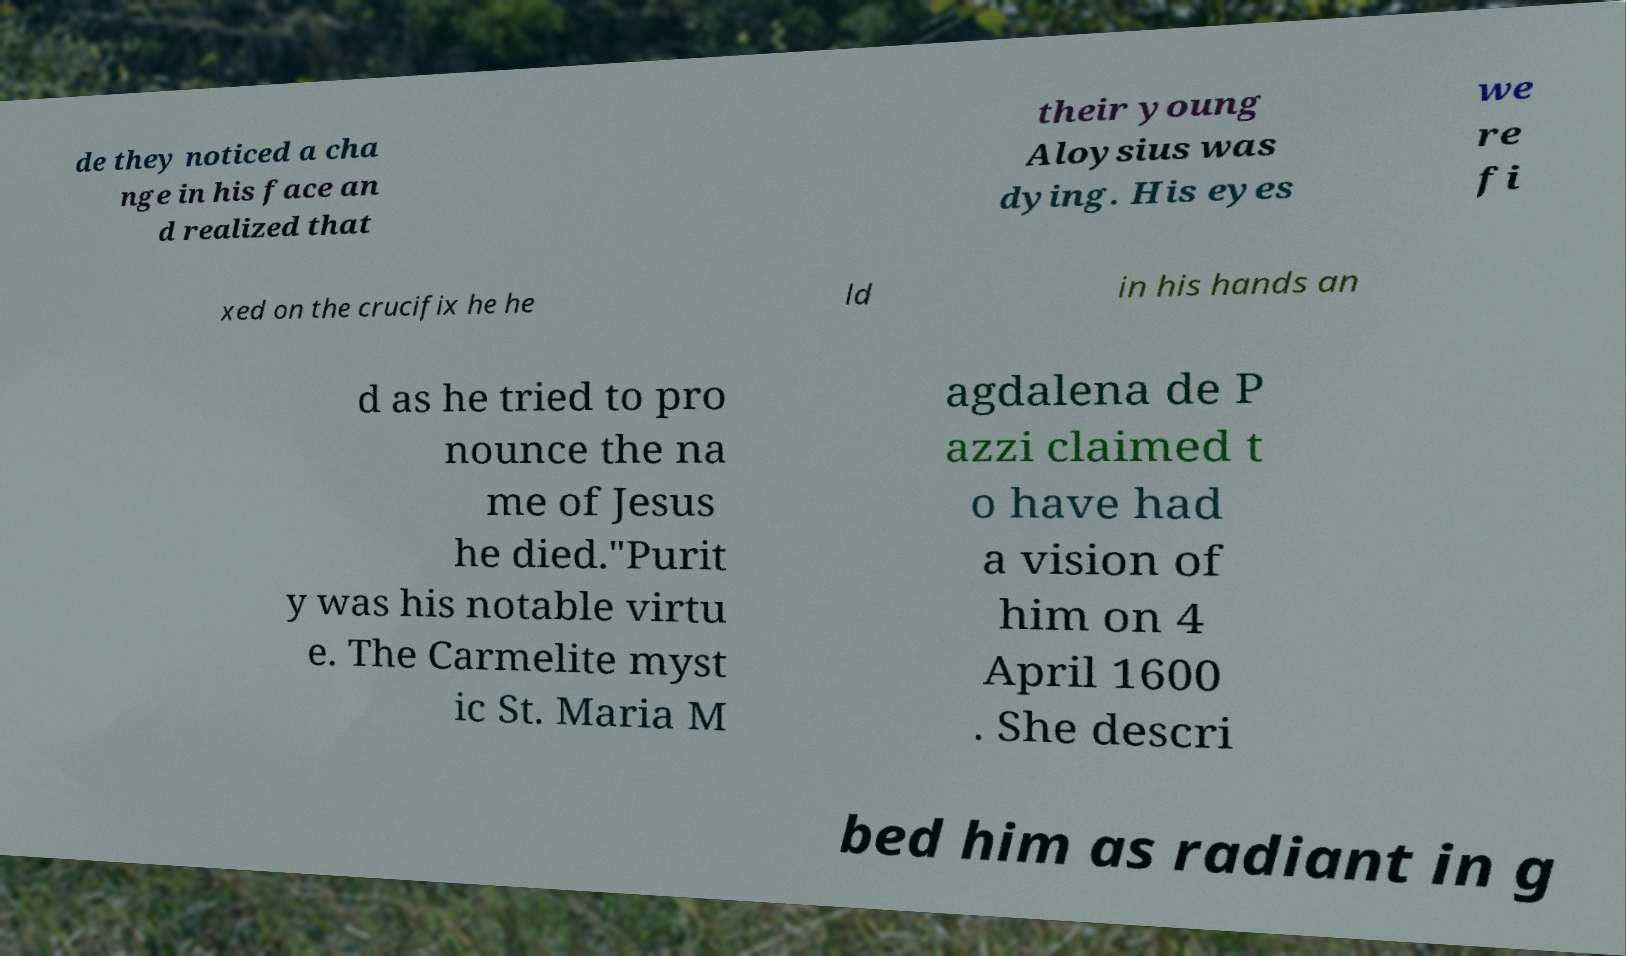Please read and relay the text visible in this image. What does it say? de they noticed a cha nge in his face an d realized that their young Aloysius was dying. His eyes we re fi xed on the crucifix he he ld in his hands an d as he tried to pro nounce the na me of Jesus he died."Purit y was his notable virtu e. The Carmelite myst ic St. Maria M agdalena de P azzi claimed t o have had a vision of him on 4 April 1600 . She descri bed him as radiant in g 